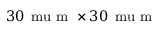<formula> <loc_0><loc_0><loc_500><loc_500>3 0 \, \ m u m \times 3 0 \, \ m u m</formula> 